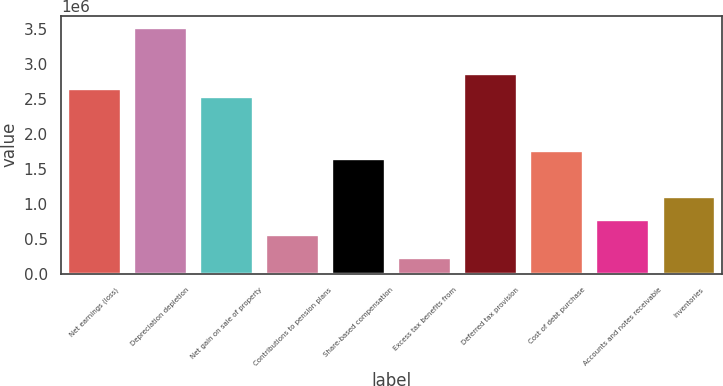<chart> <loc_0><loc_0><loc_500><loc_500><bar_chart><fcel>Net earnings (loss)<fcel>Depreciation depletion<fcel>Net gain on sale of property<fcel>Contributions to pension plans<fcel>Share-based compensation<fcel>Excess tax benefits from<fcel>Deferred tax provision<fcel>Cost of debt purchase<fcel>Accounts and notes receivable<fcel>Inventories<nl><fcel>2.64e+06<fcel>3.52e+06<fcel>2.53e+06<fcel>550001<fcel>1.65e+06<fcel>220002<fcel>2.86e+06<fcel>1.76e+06<fcel>770001<fcel>1.1e+06<nl></chart> 